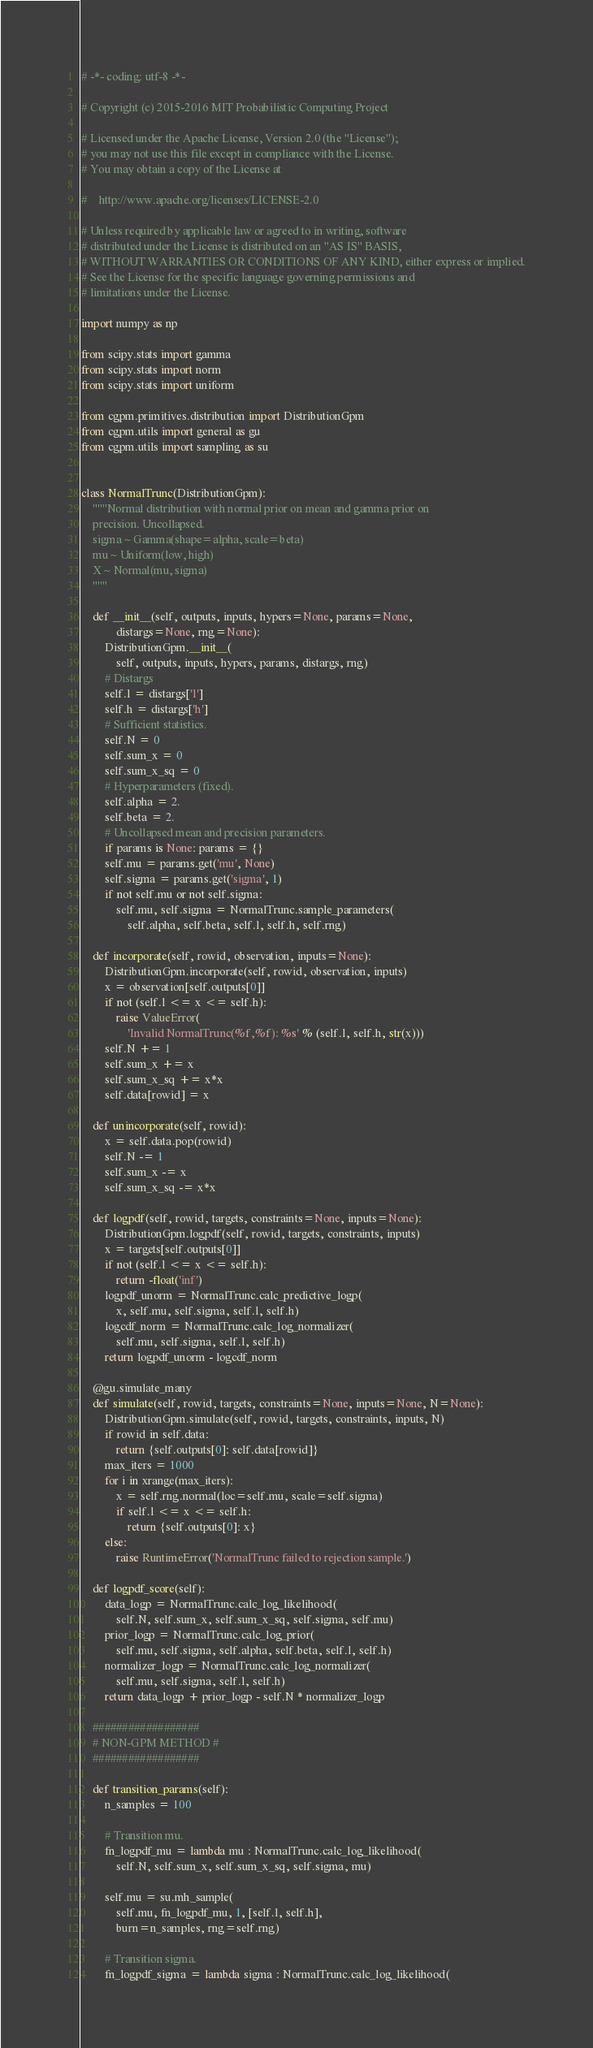<code> <loc_0><loc_0><loc_500><loc_500><_Python_># -*- coding: utf-8 -*-

# Copyright (c) 2015-2016 MIT Probabilistic Computing Project

# Licensed under the Apache License, Version 2.0 (the "License");
# you may not use this file except in compliance with the License.
# You may obtain a copy of the License at

#    http://www.apache.org/licenses/LICENSE-2.0

# Unless required by applicable law or agreed to in writing, software
# distributed under the License is distributed on an "AS IS" BASIS,
# WITHOUT WARRANTIES OR CONDITIONS OF ANY KIND, either express or implied.
# See the License for the specific language governing permissions and
# limitations under the License.

import numpy as np

from scipy.stats import gamma
from scipy.stats import norm
from scipy.stats import uniform

from cgpm.primitives.distribution import DistributionGpm
from cgpm.utils import general as gu
from cgpm.utils import sampling as su


class NormalTrunc(DistributionGpm):
    """Normal distribution with normal prior on mean and gamma prior on
    precision. Uncollapsed.
    sigma ~ Gamma(shape=alpha, scale=beta)
    mu ~ Uniform(low, high)
    X ~ Normal(mu, sigma)
    """

    def __init__(self, outputs, inputs, hypers=None, params=None,
            distargs=None, rng=None):
        DistributionGpm.__init__(
            self, outputs, inputs, hypers, params, distargs, rng)
        # Distargs
        self.l = distargs['l']
        self.h = distargs['h']
        # Sufficient statistics.
        self.N = 0
        self.sum_x = 0
        self.sum_x_sq = 0
        # Hyperparameters (fixed).
        self.alpha = 2.
        self.beta = 2.
        # Uncollapsed mean and precision parameters.
        if params is None: params = {}
        self.mu = params.get('mu', None)
        self.sigma = params.get('sigma', 1)
        if not self.mu or not self.sigma:
            self.mu, self.sigma = NormalTrunc.sample_parameters(
                self.alpha, self.beta, self.l, self.h, self.rng)

    def incorporate(self, rowid, observation, inputs=None):
        DistributionGpm.incorporate(self, rowid, observation, inputs)
        x = observation[self.outputs[0]]
        if not (self.l <= x <= self.h):
            raise ValueError(
                'Invalid NormalTrunc(%f,%f): %s' % (self.l, self.h, str(x)))
        self.N += 1
        self.sum_x += x
        self.sum_x_sq += x*x
        self.data[rowid] = x

    def unincorporate(self, rowid):
        x = self.data.pop(rowid)
        self.N -= 1
        self.sum_x -= x
        self.sum_x_sq -= x*x

    def logpdf(self, rowid, targets, constraints=None, inputs=None):
        DistributionGpm.logpdf(self, rowid, targets, constraints, inputs)
        x = targets[self.outputs[0]]
        if not (self.l <= x <= self.h):
            return -float('inf')
        logpdf_unorm = NormalTrunc.calc_predictive_logp(
            x, self.mu, self.sigma, self.l, self.h)
        logcdf_norm = NormalTrunc.calc_log_normalizer(
            self.mu, self.sigma, self.l, self.h)
        return logpdf_unorm - logcdf_norm

    @gu.simulate_many
    def simulate(self, rowid, targets, constraints=None, inputs=None, N=None):
        DistributionGpm.simulate(self, rowid, targets, constraints, inputs, N)
        if rowid in self.data:
            return {self.outputs[0]: self.data[rowid]}
        max_iters = 1000
        for i in xrange(max_iters):
            x = self.rng.normal(loc=self.mu, scale=self.sigma)
            if self.l <= x <= self.h:
                return {self.outputs[0]: x}
        else:
            raise RuntimeError('NormalTrunc failed to rejection sample.')

    def logpdf_score(self):
        data_logp = NormalTrunc.calc_log_likelihood(
            self.N, self.sum_x, self.sum_x_sq, self.sigma, self.mu)
        prior_logp = NormalTrunc.calc_log_prior(
            self.mu, self.sigma, self.alpha, self.beta, self.l, self.h)
        normalizer_logp = NormalTrunc.calc_log_normalizer(
            self.mu, self.sigma, self.l, self.h)
        return data_logp + prior_logp - self.N * normalizer_logp

    ##################
    # NON-GPM METHOD #
    ##################

    def transition_params(self):
        n_samples = 100

        # Transition mu.
        fn_logpdf_mu = lambda mu : NormalTrunc.calc_log_likelihood(
            self.N, self.sum_x, self.sum_x_sq, self.sigma, mu)

        self.mu = su.mh_sample(
            self.mu, fn_logpdf_mu, 1, [self.l, self.h],
            burn=n_samples, rng=self.rng)

        # Transition sigma.
        fn_logpdf_sigma = lambda sigma : NormalTrunc.calc_log_likelihood(</code> 